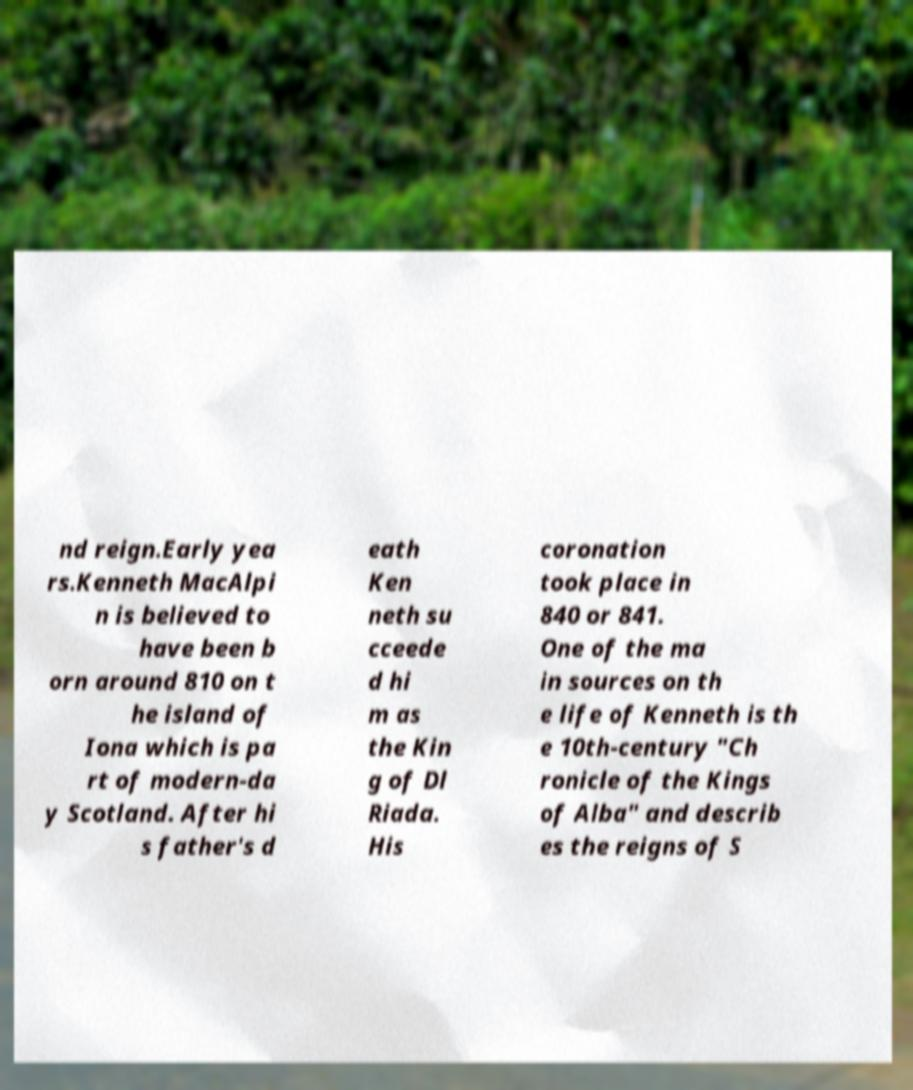What messages or text are displayed in this image? I need them in a readable, typed format. nd reign.Early yea rs.Kenneth MacAlpi n is believed to have been b orn around 810 on t he island of Iona which is pa rt of modern-da y Scotland. After hi s father's d eath Ken neth su cceede d hi m as the Kin g of Dl Riada. His coronation took place in 840 or 841. One of the ma in sources on th e life of Kenneth is th e 10th-century "Ch ronicle of the Kings of Alba" and describ es the reigns of S 